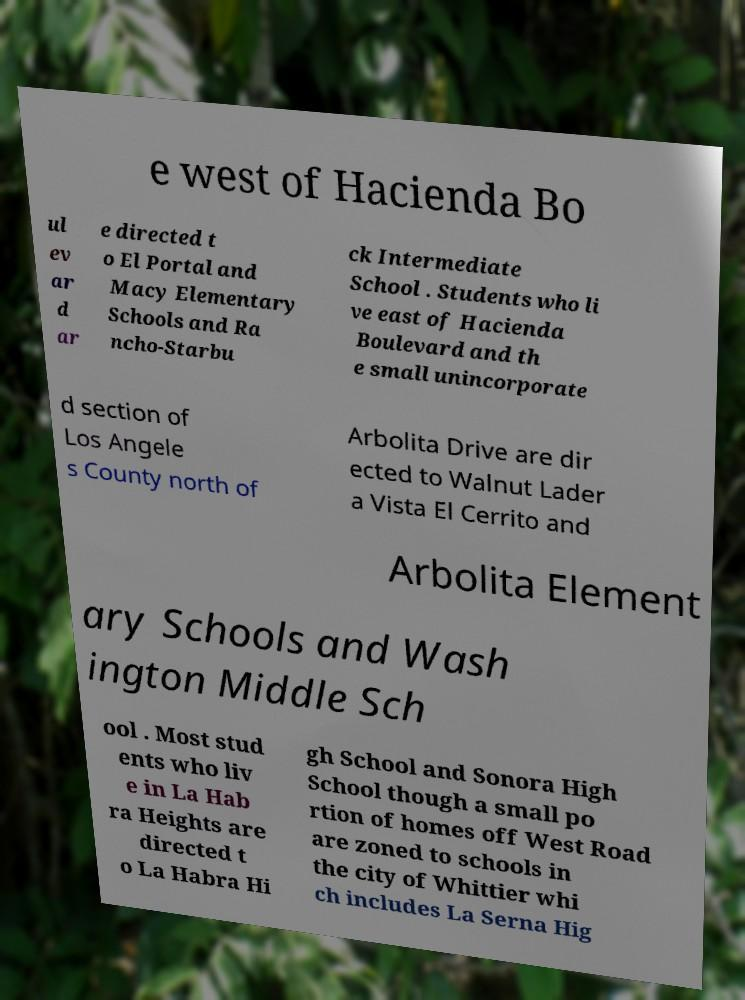For documentation purposes, I need the text within this image transcribed. Could you provide that? e west of Hacienda Bo ul ev ar d ar e directed t o El Portal and Macy Elementary Schools and Ra ncho-Starbu ck Intermediate School . Students who li ve east of Hacienda Boulevard and th e small unincorporate d section of Los Angele s County north of Arbolita Drive are dir ected to Walnut Lader a Vista El Cerrito and Arbolita Element ary Schools and Wash ington Middle Sch ool . Most stud ents who liv e in La Hab ra Heights are directed t o La Habra Hi gh School and Sonora High School though a small po rtion of homes off West Road are zoned to schools in the city of Whittier whi ch includes La Serna Hig 